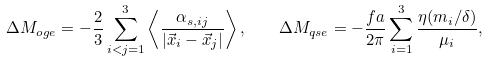Convert formula to latex. <formula><loc_0><loc_0><loc_500><loc_500>\Delta M _ { o g e } = - \frac { 2 } { 3 } \sum ^ { 3 } _ { i < j = 1 } \left \langle \frac { \alpha _ { s , i j } } { | \vec { x } _ { i } - \vec { x } _ { j } | } \right \rangle , \quad \Delta M _ { q s e } = - \frac { f a } { 2 \pi } \sum ^ { 3 } _ { i = 1 } \frac { \eta ( m _ { i } / \delta ) } { \mu _ { i } } ,</formula> 